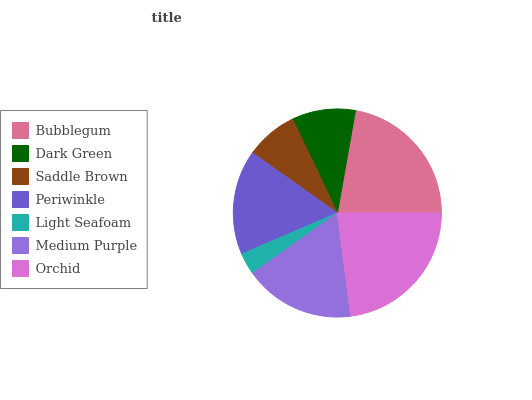Is Light Seafoam the minimum?
Answer yes or no. Yes. Is Orchid the maximum?
Answer yes or no. Yes. Is Dark Green the minimum?
Answer yes or no. No. Is Dark Green the maximum?
Answer yes or no. No. Is Bubblegum greater than Dark Green?
Answer yes or no. Yes. Is Dark Green less than Bubblegum?
Answer yes or no. Yes. Is Dark Green greater than Bubblegum?
Answer yes or no. No. Is Bubblegum less than Dark Green?
Answer yes or no. No. Is Periwinkle the high median?
Answer yes or no. Yes. Is Periwinkle the low median?
Answer yes or no. Yes. Is Orchid the high median?
Answer yes or no. No. Is Light Seafoam the low median?
Answer yes or no. No. 